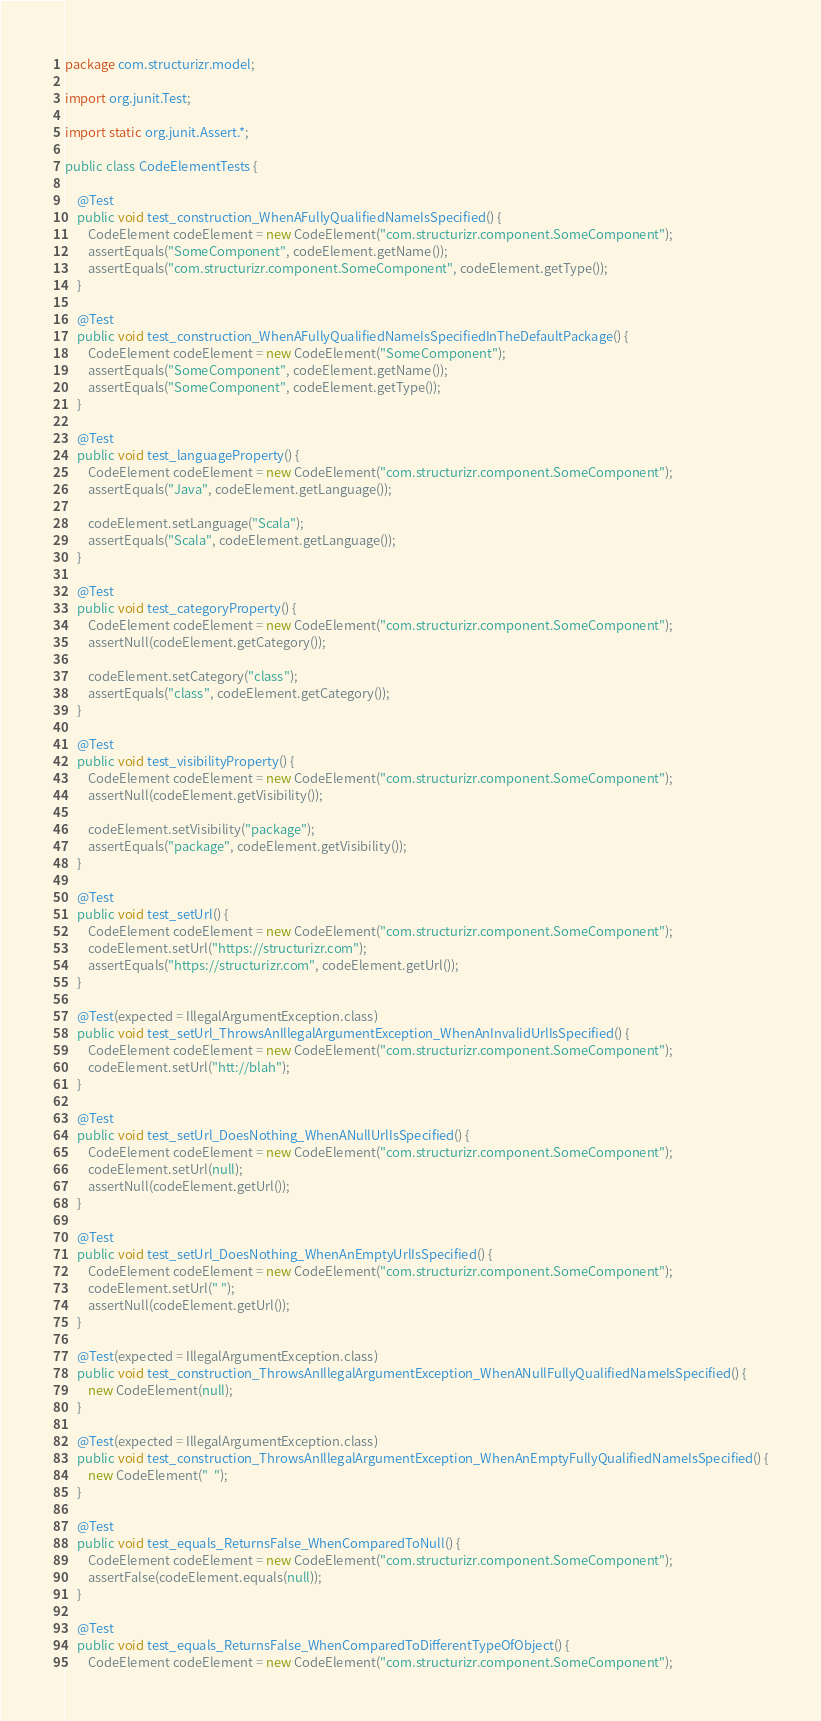<code> <loc_0><loc_0><loc_500><loc_500><_Java_>package com.structurizr.model;

import org.junit.Test;

import static org.junit.Assert.*;

public class CodeElementTests {

    @Test
    public void test_construction_WhenAFullyQualifiedNameIsSpecified() {
        CodeElement codeElement = new CodeElement("com.structurizr.component.SomeComponent");
        assertEquals("SomeComponent", codeElement.getName());
        assertEquals("com.structurizr.component.SomeComponent", codeElement.getType());
    }

    @Test
    public void test_construction_WhenAFullyQualifiedNameIsSpecifiedInTheDefaultPackage() {
        CodeElement codeElement = new CodeElement("SomeComponent");
        assertEquals("SomeComponent", codeElement.getName());
        assertEquals("SomeComponent", codeElement.getType());
    }

    @Test
    public void test_languageProperty() {
        CodeElement codeElement = new CodeElement("com.structurizr.component.SomeComponent");
        assertEquals("Java", codeElement.getLanguage());

        codeElement.setLanguage("Scala");
        assertEquals("Scala", codeElement.getLanguage());
    }

    @Test
    public void test_categoryProperty() {
        CodeElement codeElement = new CodeElement("com.structurizr.component.SomeComponent");
        assertNull(codeElement.getCategory());

        codeElement.setCategory("class");
        assertEquals("class", codeElement.getCategory());
    }

    @Test
    public void test_visibilityProperty() {
        CodeElement codeElement = new CodeElement("com.structurizr.component.SomeComponent");
        assertNull(codeElement.getVisibility());

        codeElement.setVisibility("package");
        assertEquals("package", codeElement.getVisibility());
    }

    @Test
    public void test_setUrl() {
        CodeElement codeElement = new CodeElement("com.structurizr.component.SomeComponent");
        codeElement.setUrl("https://structurizr.com");
        assertEquals("https://structurizr.com", codeElement.getUrl());
    }

    @Test(expected = IllegalArgumentException.class)
    public void test_setUrl_ThrowsAnIllegalArgumentException_WhenAnInvalidUrlIsSpecified() {
        CodeElement codeElement = new CodeElement("com.structurizr.component.SomeComponent");
        codeElement.setUrl("htt://blah");
    }

    @Test
    public void test_setUrl_DoesNothing_WhenANullUrlIsSpecified() {
        CodeElement codeElement = new CodeElement("com.structurizr.component.SomeComponent");
        codeElement.setUrl(null);
        assertNull(codeElement.getUrl());
    }

    @Test
    public void test_setUrl_DoesNothing_WhenAnEmptyUrlIsSpecified() {
        CodeElement codeElement = new CodeElement("com.structurizr.component.SomeComponent");
        codeElement.setUrl(" ");
        assertNull(codeElement.getUrl());
    }

    @Test(expected = IllegalArgumentException.class)
    public void test_construction_ThrowsAnIllegalArgumentException_WhenANullFullyQualifiedNameIsSpecified() {
        new CodeElement(null);
    }

    @Test(expected = IllegalArgumentException.class)
    public void test_construction_ThrowsAnIllegalArgumentException_WhenAnEmptyFullyQualifiedNameIsSpecified() {
        new CodeElement("  ");
    }

    @Test
    public void test_equals_ReturnsFalse_WhenComparedToNull() {
        CodeElement codeElement = new CodeElement("com.structurizr.component.SomeComponent");
        assertFalse(codeElement.equals(null));
    }

    @Test
    public void test_equals_ReturnsFalse_WhenComparedToDifferentTypeOfObject() {
        CodeElement codeElement = new CodeElement("com.structurizr.component.SomeComponent");</code> 